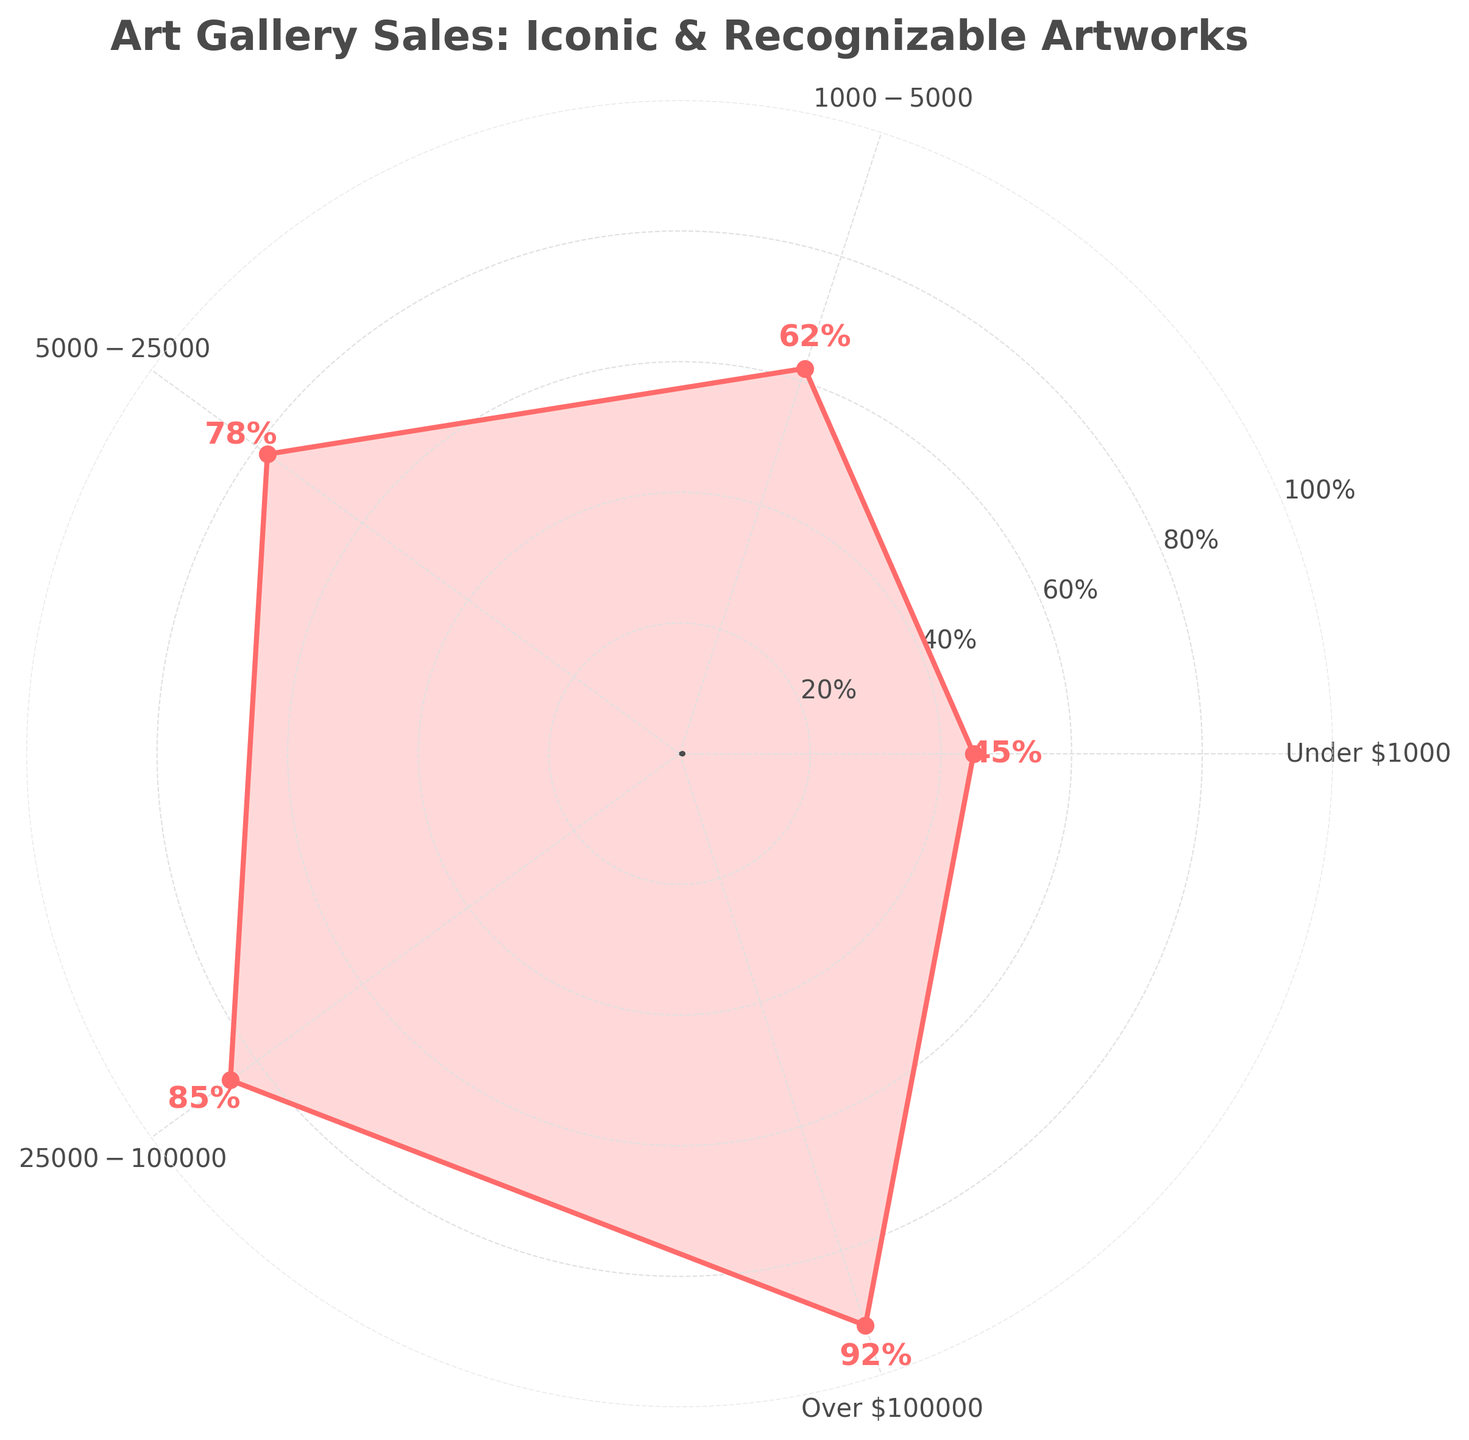What's the title of the chart? The title of the chart is displayed at the top in a larger and bold font. It reads "Art Gallery Sales: Iconic & Recognizable Artworks".
Answer: Art Gallery Sales: Iconic & Recognizable Artworks How many price ranges are displayed on the chart? There are labels at each angle around the circular plot representing different price ranges. By counting these labels, you find that there are 5 price ranges.
Answer: 5 What is the percentage of art gallery sales attributed to iconic and recognizable artworks in the $5000-$25000 price range? Look at the label corresponding to the $5000-$25000 price range and read the percentage value associated with it. The chart shows that the percentage is 78%.
Answer: 78% Which price range has the highest percentage of art gallery sales attributed to iconic and recognizable artworks? Check all the percentage values around the circular plot and identify the highest one. The "Over $100000" price range has the highest percentage, which is 92%.
Answer: Over $100000 What is the difference in percentage between the "Under $1000" and "Over $100000" price ranges? Find the percentages for both price ranges and calculate the difference. The percentage for "Under $1000" is 45% and for "Over $100000" it is 92%. The difference is 92% - 45% = 47%.
Answer: 47% Which price range shows a percentage of sales between 60% and 80%? Examine each price range to see which one falls within the 60% to 80% range. The "$1000-$5000" price range has 62%, which falls between 60% and 80%. Similarly, the "$5000-$25000" range at 78% also falls within this range.
Answer: $1000-$5000 and $5000-$25000 Is the percentage of sales for price ranges generally increasing or decreasing? Observe the trend in percentage values as the price range increases from "Under $1000" to "Over $100000". The percentages consistently increase from 45% to 92%. Hence, the trend is increasing.
Answer: Increasing What is the average percentage of sales attributed to iconic and recognizable artworks across all price ranges? Add up the percentages for all price ranges and divide by the number of price ranges. The percentages are 45%, 62%, 78%, 85%, and 92%. The sum is 45 + 62 + 78 + 85 + 92 = 362. There are 5 price ranges, so the average is 362/5 = 72.4%.
Answer: 72.4% Which price range has a percentage closest to the average percentage of sales? The average percentage of sales is 72.4%. Compare this average to each price range's percentage: 45%, 62%, 78%, 85%, and 92%. The "$5000-$25000" price range at 78% is closest to 72.4%.
Answer: $5000-$25000 